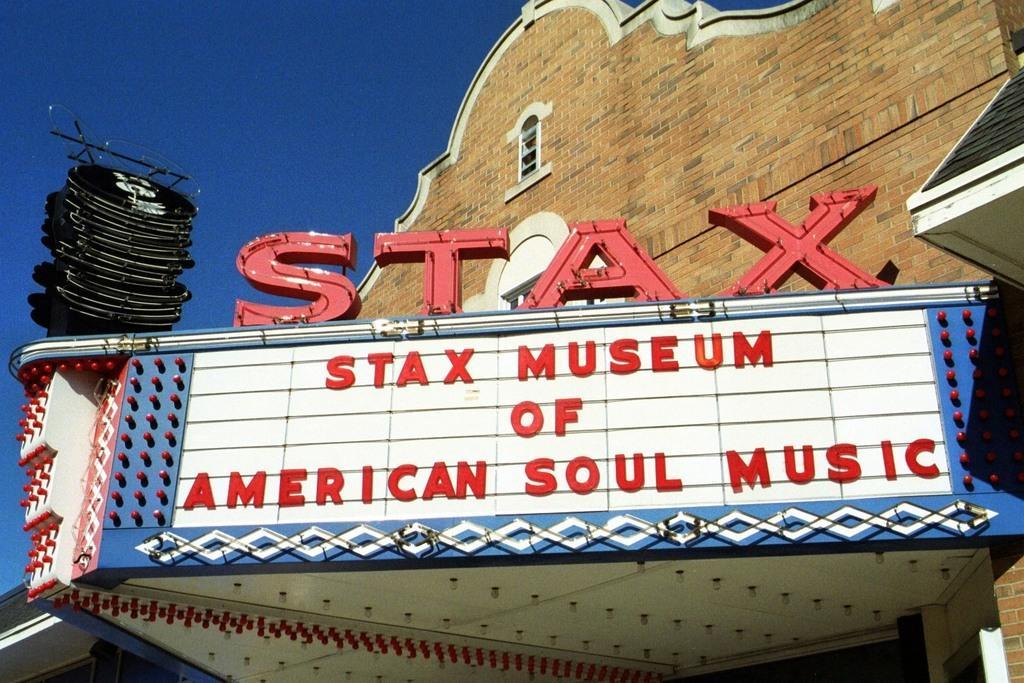Can you describe this image briefly? In this picture we can see some text, lights, brick wall, black object and other objects are visible on a building. Sky is blue in color. 